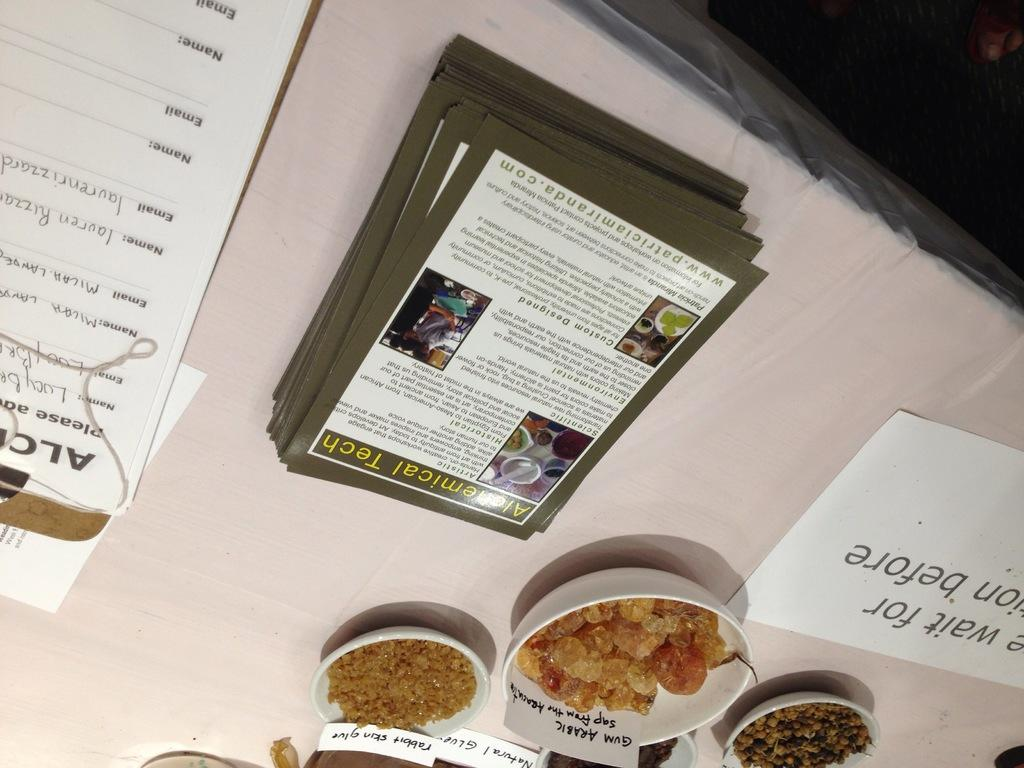What is the main piece of furniture in the image? There is a table in the image. What items can be seen on the table? There are papers, bowls, and grains on the table. What type of locket is hanging from the table in the image? There is no locket present in the image; it only features a table with papers, bowls, and grains. 